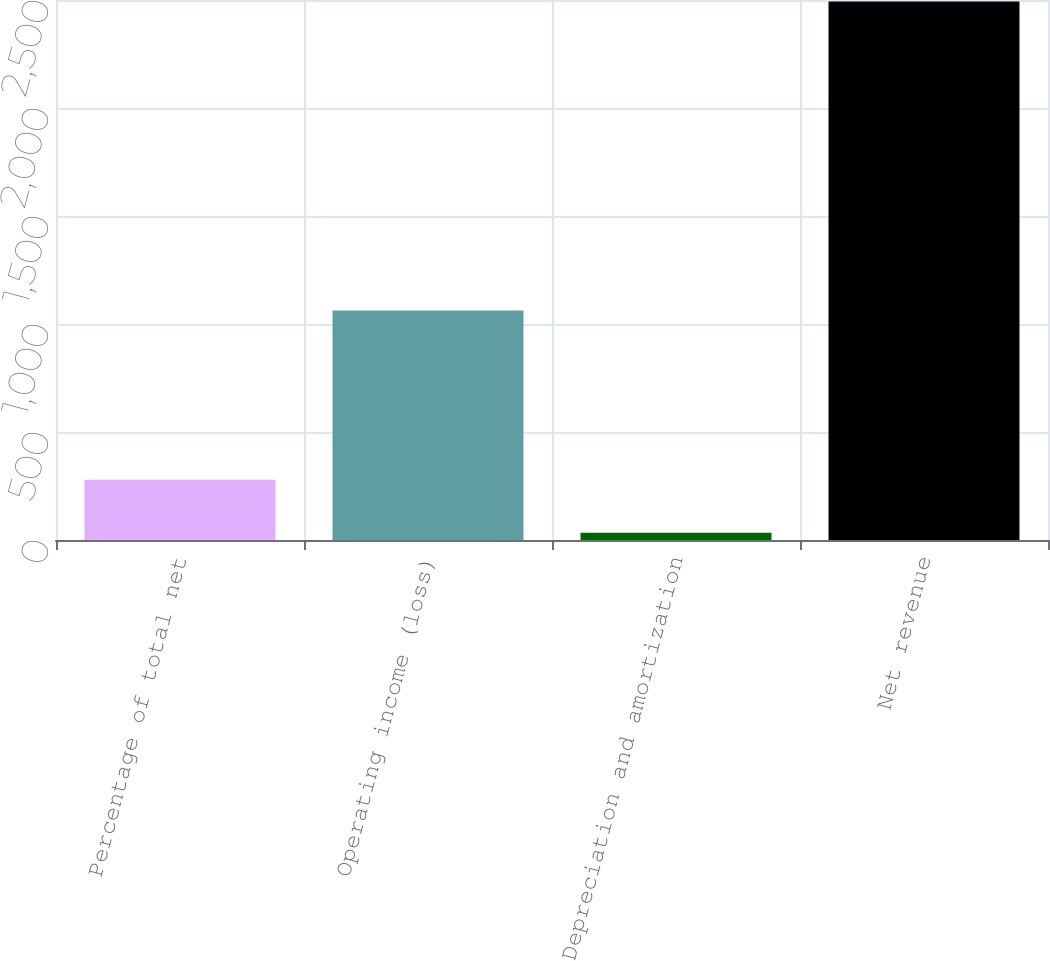Convert chart to OTSL. <chart><loc_0><loc_0><loc_500><loc_500><bar_chart><fcel>Percentage of total net<fcel>Operating income (loss)<fcel>Depreciation and amortization<fcel>Net revenue<nl><fcel>279<fcel>1063<fcel>33<fcel>2493<nl></chart> 